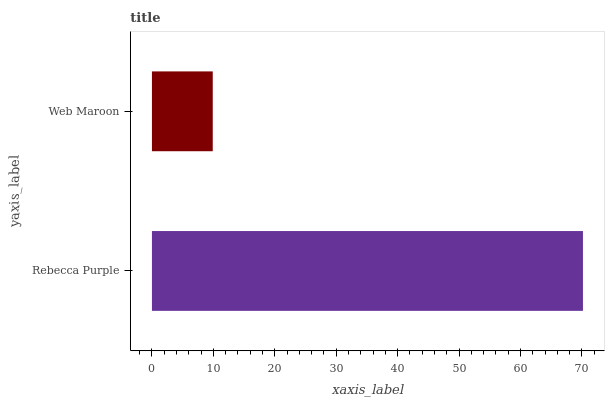Is Web Maroon the minimum?
Answer yes or no. Yes. Is Rebecca Purple the maximum?
Answer yes or no. Yes. Is Web Maroon the maximum?
Answer yes or no. No. Is Rebecca Purple greater than Web Maroon?
Answer yes or no. Yes. Is Web Maroon less than Rebecca Purple?
Answer yes or no. Yes. Is Web Maroon greater than Rebecca Purple?
Answer yes or no. No. Is Rebecca Purple less than Web Maroon?
Answer yes or no. No. Is Rebecca Purple the high median?
Answer yes or no. Yes. Is Web Maroon the low median?
Answer yes or no. Yes. Is Web Maroon the high median?
Answer yes or no. No. Is Rebecca Purple the low median?
Answer yes or no. No. 